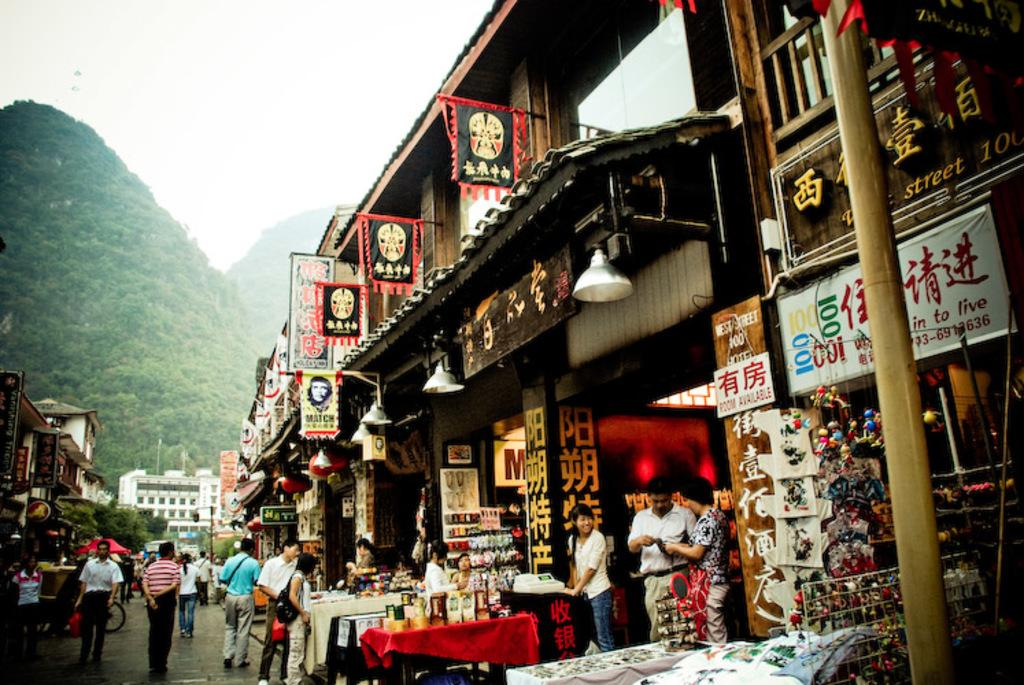<image>
Offer a succinct explanation of the picture presented. Many people are outside of West Street Hotel. 